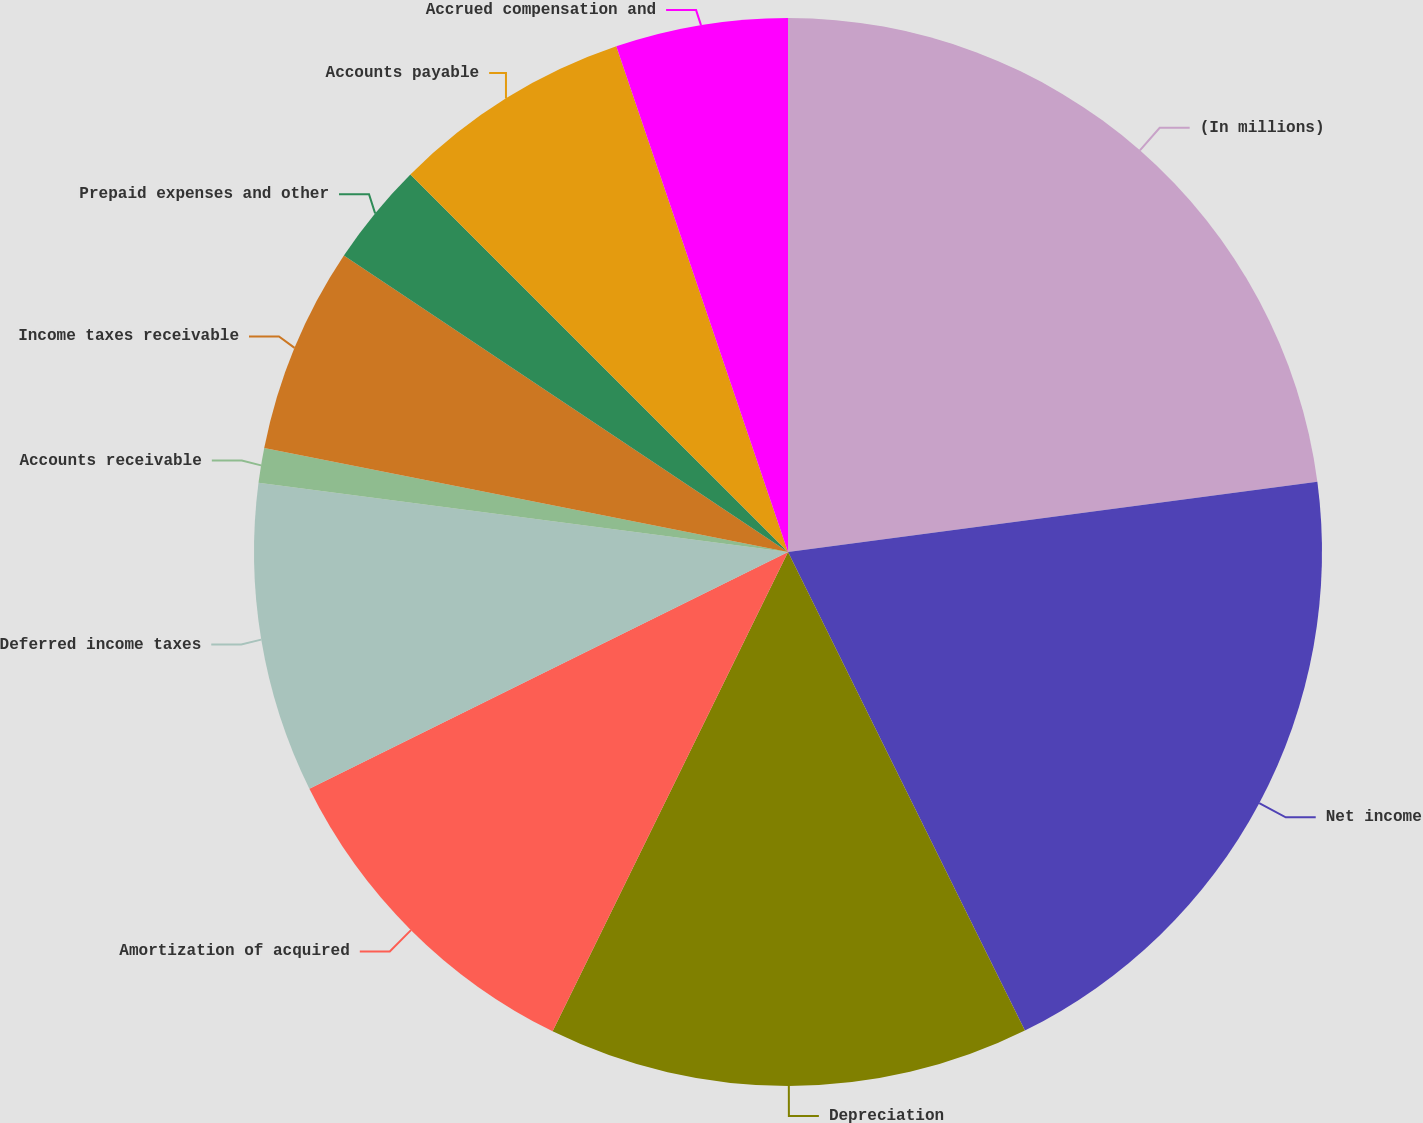<chart> <loc_0><loc_0><loc_500><loc_500><pie_chart><fcel>(In millions)<fcel>Net income<fcel>Depreciation<fcel>Amortization of acquired<fcel>Deferred income taxes<fcel>Accounts receivable<fcel>Income taxes receivable<fcel>Prepaid expenses and other<fcel>Accounts payable<fcel>Accrued compensation and<nl><fcel>22.9%<fcel>19.78%<fcel>14.58%<fcel>10.42%<fcel>9.38%<fcel>1.05%<fcel>6.25%<fcel>3.13%<fcel>7.29%<fcel>5.21%<nl></chart> 